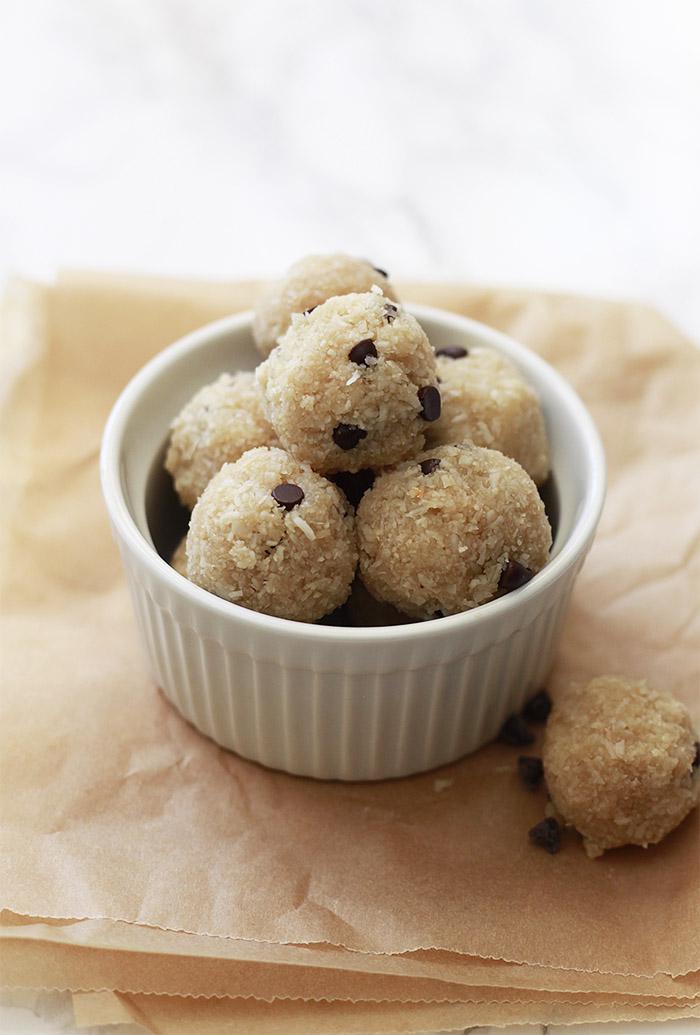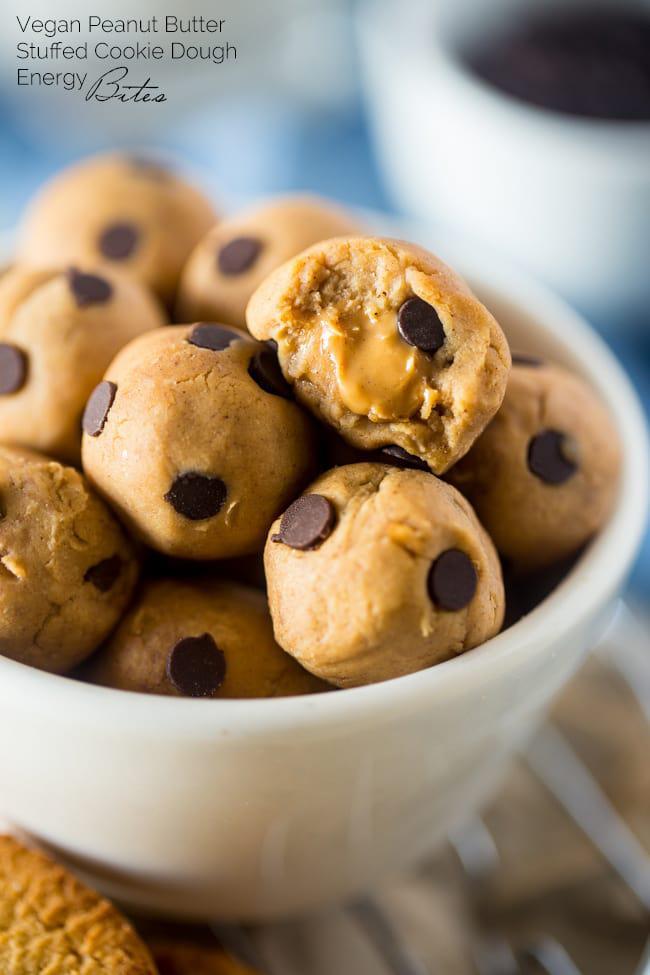The first image is the image on the left, the second image is the image on the right. Analyze the images presented: Is the assertion "The cookies in the left image are resting in a white dish." valid? Answer yes or no. Yes. The first image is the image on the left, the second image is the image on the right. Given the left and right images, does the statement "Every photo shows balls of dough inside of a bowl." hold true? Answer yes or no. Yes. 